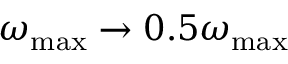Convert formula to latex. <formula><loc_0><loc_0><loc_500><loc_500>\omega _ { \max } \to 0 . 5 \omega _ { \max }</formula> 